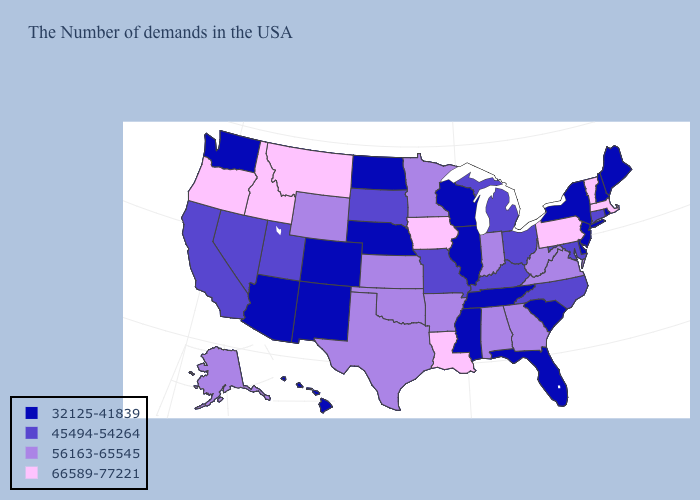Among the states that border Idaho , which have the highest value?
Answer briefly. Montana, Oregon. What is the highest value in the USA?
Write a very short answer. 66589-77221. What is the lowest value in the USA?
Quick response, please. 32125-41839. What is the lowest value in the USA?
Concise answer only. 32125-41839. Does the map have missing data?
Give a very brief answer. No. Which states have the highest value in the USA?
Keep it brief. Massachusetts, Vermont, Pennsylvania, Louisiana, Iowa, Montana, Idaho, Oregon. Name the states that have a value in the range 45494-54264?
Answer briefly. Connecticut, Maryland, North Carolina, Ohio, Michigan, Kentucky, Missouri, South Dakota, Utah, Nevada, California. Does Alaska have the highest value in the USA?
Answer briefly. No. Name the states that have a value in the range 45494-54264?
Short answer required. Connecticut, Maryland, North Carolina, Ohio, Michigan, Kentucky, Missouri, South Dakota, Utah, Nevada, California. How many symbols are there in the legend?
Concise answer only. 4. Does Massachusetts have the highest value in the Northeast?
Concise answer only. Yes. Name the states that have a value in the range 66589-77221?
Write a very short answer. Massachusetts, Vermont, Pennsylvania, Louisiana, Iowa, Montana, Idaho, Oregon. What is the highest value in the USA?
Be succinct. 66589-77221. What is the value of Pennsylvania?
Write a very short answer. 66589-77221. What is the lowest value in the South?
Write a very short answer. 32125-41839. 